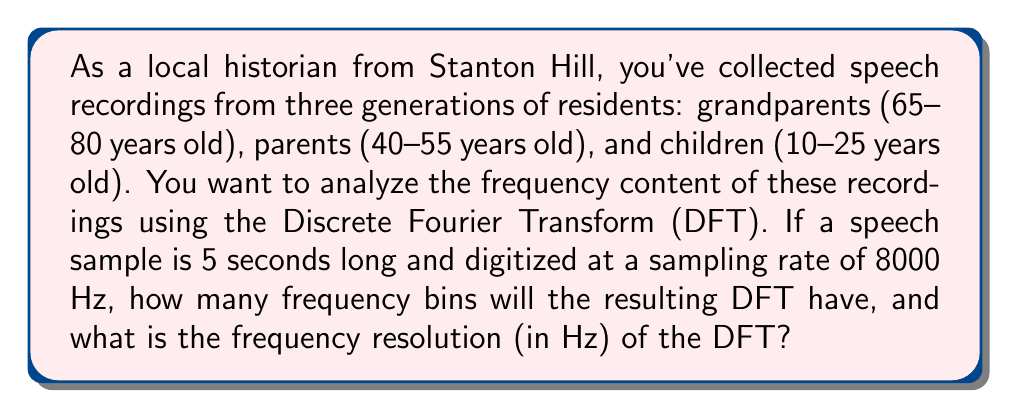Give your solution to this math problem. To solve this problem, we need to understand the relationship between the time domain signal and its frequency domain representation obtained through the Discrete Fourier Transform (DFT).

1. Calculate the total number of samples:
   - Duration of the recording: 5 seconds
   - Sampling rate: 8000 Hz (samples per second)
   - Total number of samples: $N = 5 \times 8000 = 40000$ samples

2. Determine the number of frequency bins:
   - The DFT produces the same number of frequency bins as there are samples in the time domain signal.
   - Therefore, the number of frequency bins is also 40000.

3. Calculate the frequency resolution:
   - The frequency resolution is given by the formula: $\Delta f = \frac{f_s}{N}$
   - Where $f_s$ is the sampling frequency and $N$ is the number of samples
   - Substituting the values:
     $$\Delta f = \frac{8000 \text{ Hz}}{40000} = 0.2 \text{ Hz}$$

This means that each frequency bin in the DFT represents a 0.2 Hz wide band of frequencies.

Note: In practice, we often use the Fast Fourier Transform (FFT) algorithm to compute the DFT efficiently. The FFT is most efficient when the number of samples is a power of 2. In this case, we might zero-pad the signal to 65536 (2^16) samples for computational efficiency, but the fundamental frequency resolution would remain the same.
Answer: The DFT will have 40000 frequency bins, and the frequency resolution will be 0.2 Hz. 